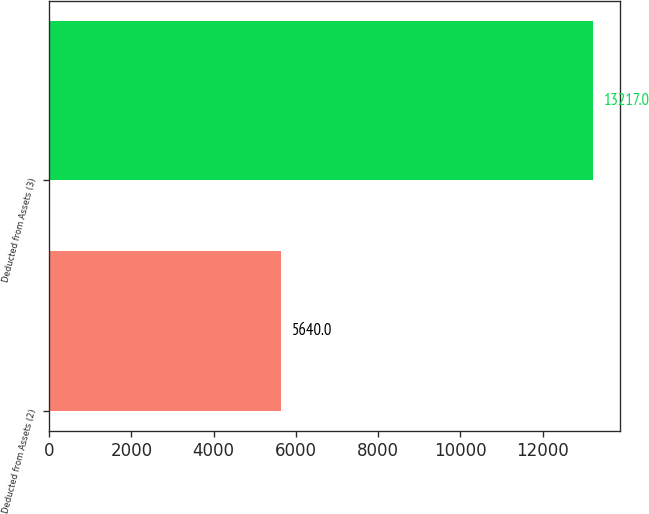Convert chart to OTSL. <chart><loc_0><loc_0><loc_500><loc_500><bar_chart><fcel>Deducted from Assets (2)<fcel>Deducted from Assets (3)<nl><fcel>5640<fcel>13217<nl></chart> 